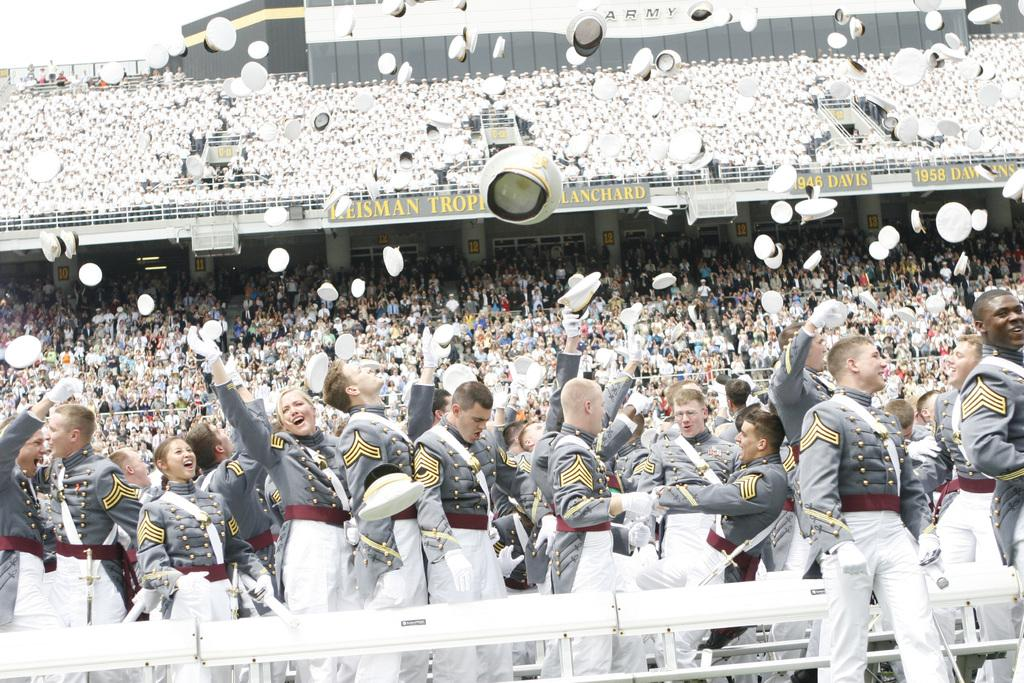What type of structure can be seen in the image? There is a fence in the image. Can you describe the people in the image? There is a group of people in the image. What are the name boards used for in the image? Name boards are present in the image. What type of headwear is visible in the image? Caps are visible in the image. What architectural elements can be seen in the image? Pillars are present in the image. What type of illumination is visible in the image? Lights are visible in the image. Are there any unspecified objects in the image? Yes, there are some unspecified objects in the image. What degree is the turkey holding in the image? There is no turkey present in the image, and therefore no degree can be observed. 